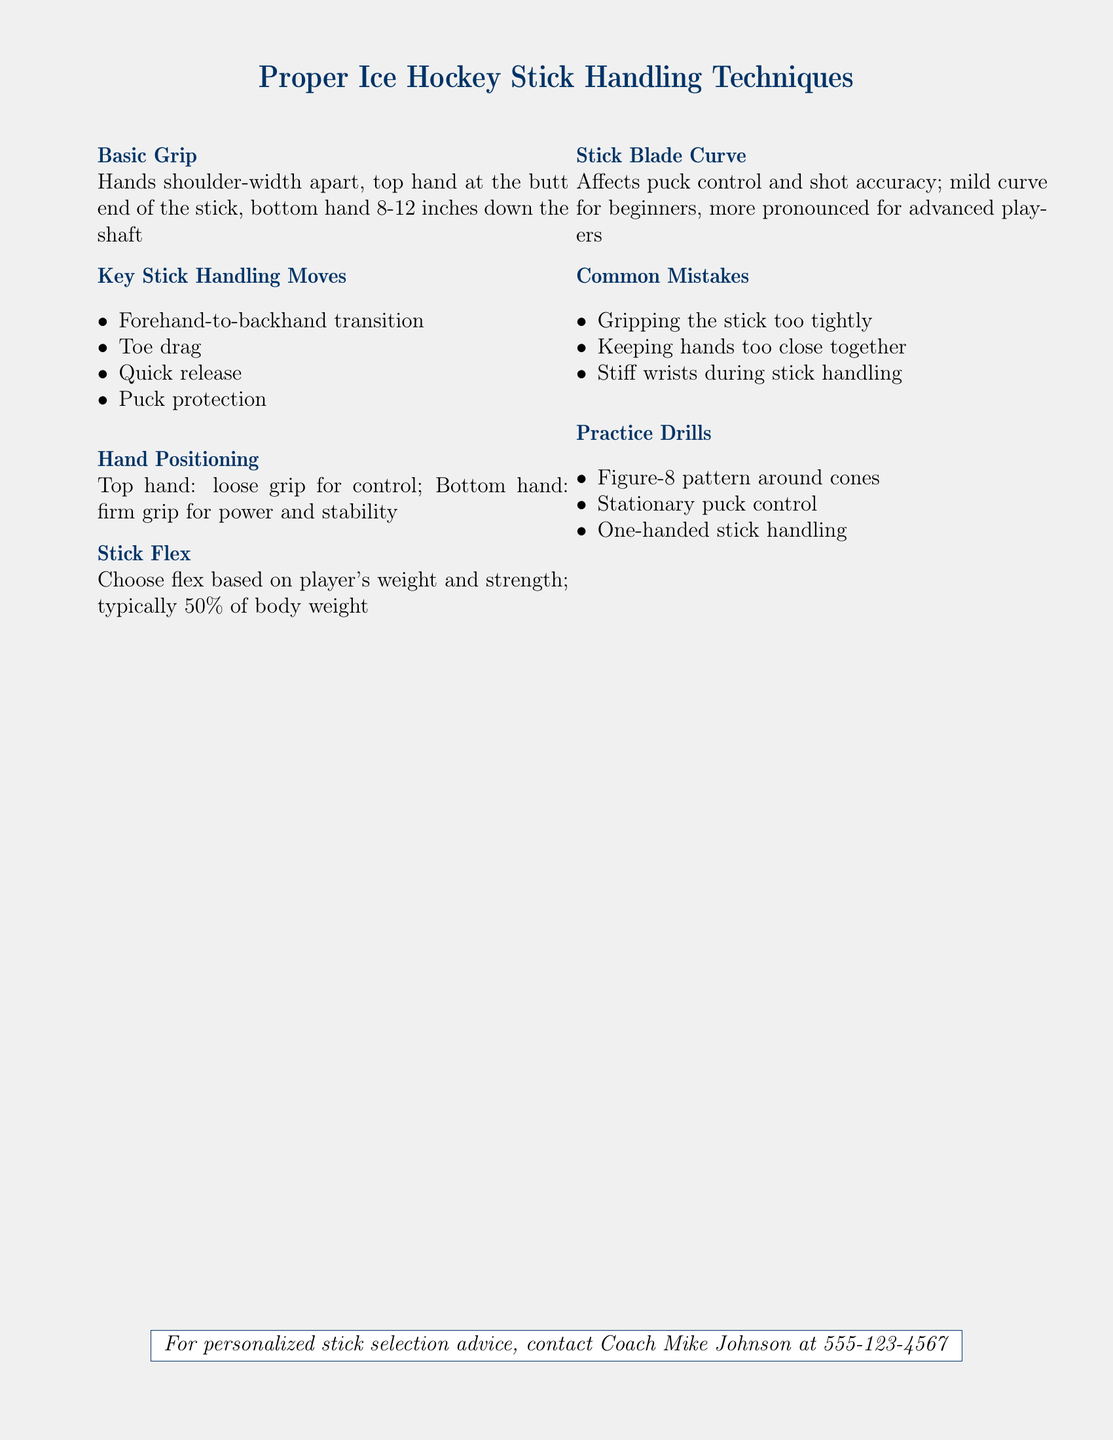What is the recommended hand positioning for stick handling? The document suggests that the top hand should have a loose grip for control, while the bottom hand should have a firm grip for power and stability.
Answer: Loose grip for control; firm grip for power and stability What are the key stick handling moves listed? The document lists four specific moves as key stick handling techniques: forehand-to-backhand transition, toe drag, quick release, and puck protection.
Answer: Forehand-to-backhand transition, toe drag, quick release, puck protection What is the stick flex recommendation based on? The recommendation for stick flex is based on the player's weight and strength, typically suggesting it should be 50% of the player's body weight.
Answer: 50% of body weight What common mistake involves the wrists? The document indicates that a common mistake is having stiff wrists during stick handling.
Answer: Stiff wrists during stick handling What is suggested for beginners regarding stick blade curve? The document suggests that beginners should choose a stick with a mild curve for better control and accuracy.
Answer: Mild curve 